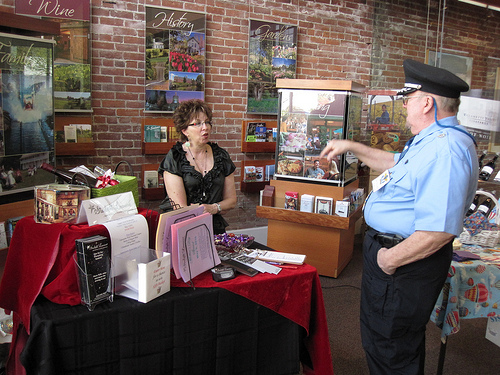<image>
Can you confirm if the books is on the table? No. The books is not positioned on the table. They may be near each other, but the books is not supported by or resting on top of the table. Where is the woman in relation to the police officer? Is it to the left of the police officer? Yes. From this viewpoint, the woman is positioned to the left side relative to the police officer. Is there a man next to the stand? Yes. The man is positioned adjacent to the stand, located nearby in the same general area. 